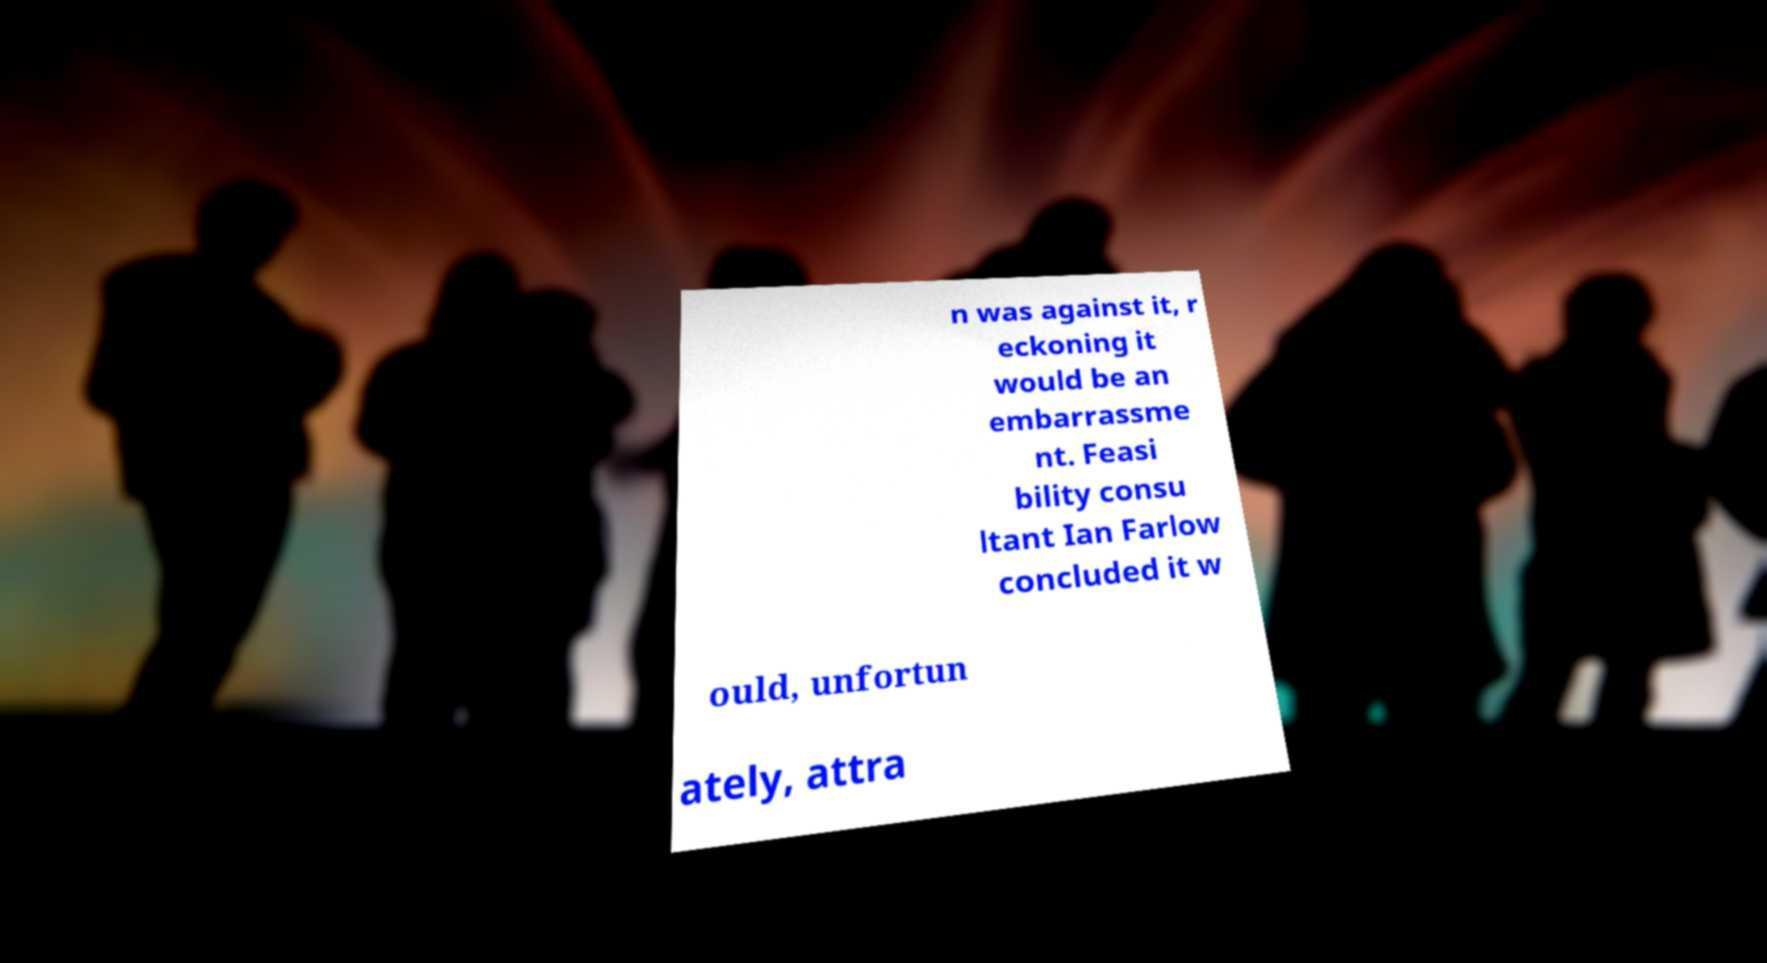Please identify and transcribe the text found in this image. n was against it, r eckoning it would be an embarrassme nt. Feasi bility consu ltant Ian Farlow concluded it w ould, unfortun ately, attra 